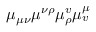Convert formula to latex. <formula><loc_0><loc_0><loc_500><loc_500>\mu _ { \mu \nu } \mu ^ { \nu \rho } \mu _ { \rho } ^ { v } \mu _ { v } ^ { \mu }</formula> 